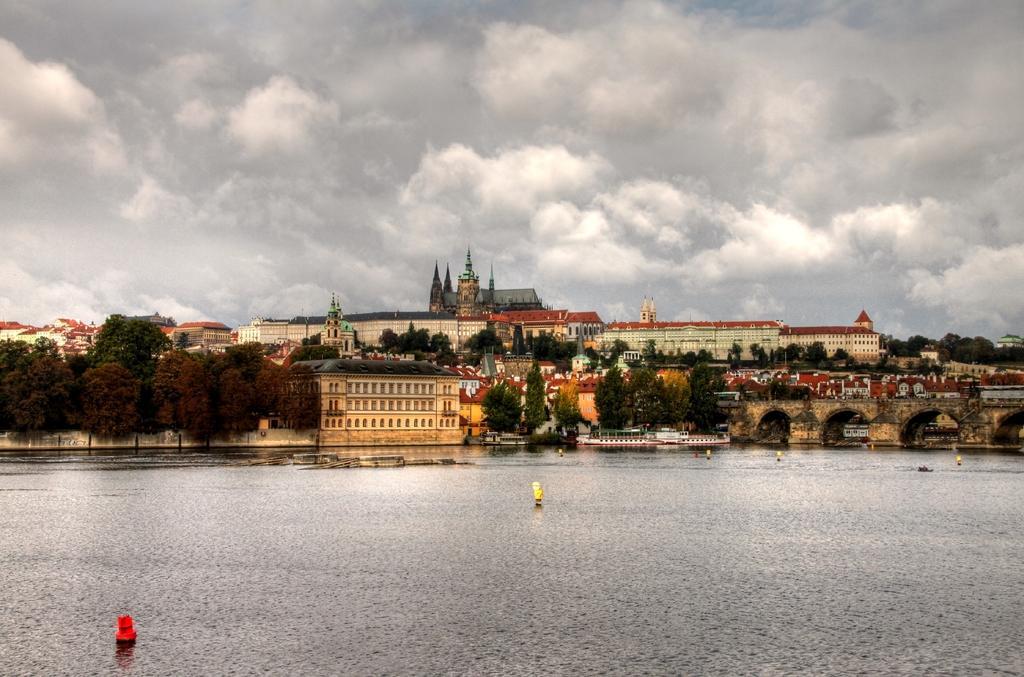Can you describe this image briefly? In this image we can see many buildings and also trees. Image also consists of boats on the surface of the river. We can also see a bridge on the right. At the top there is a cloudy sky. 